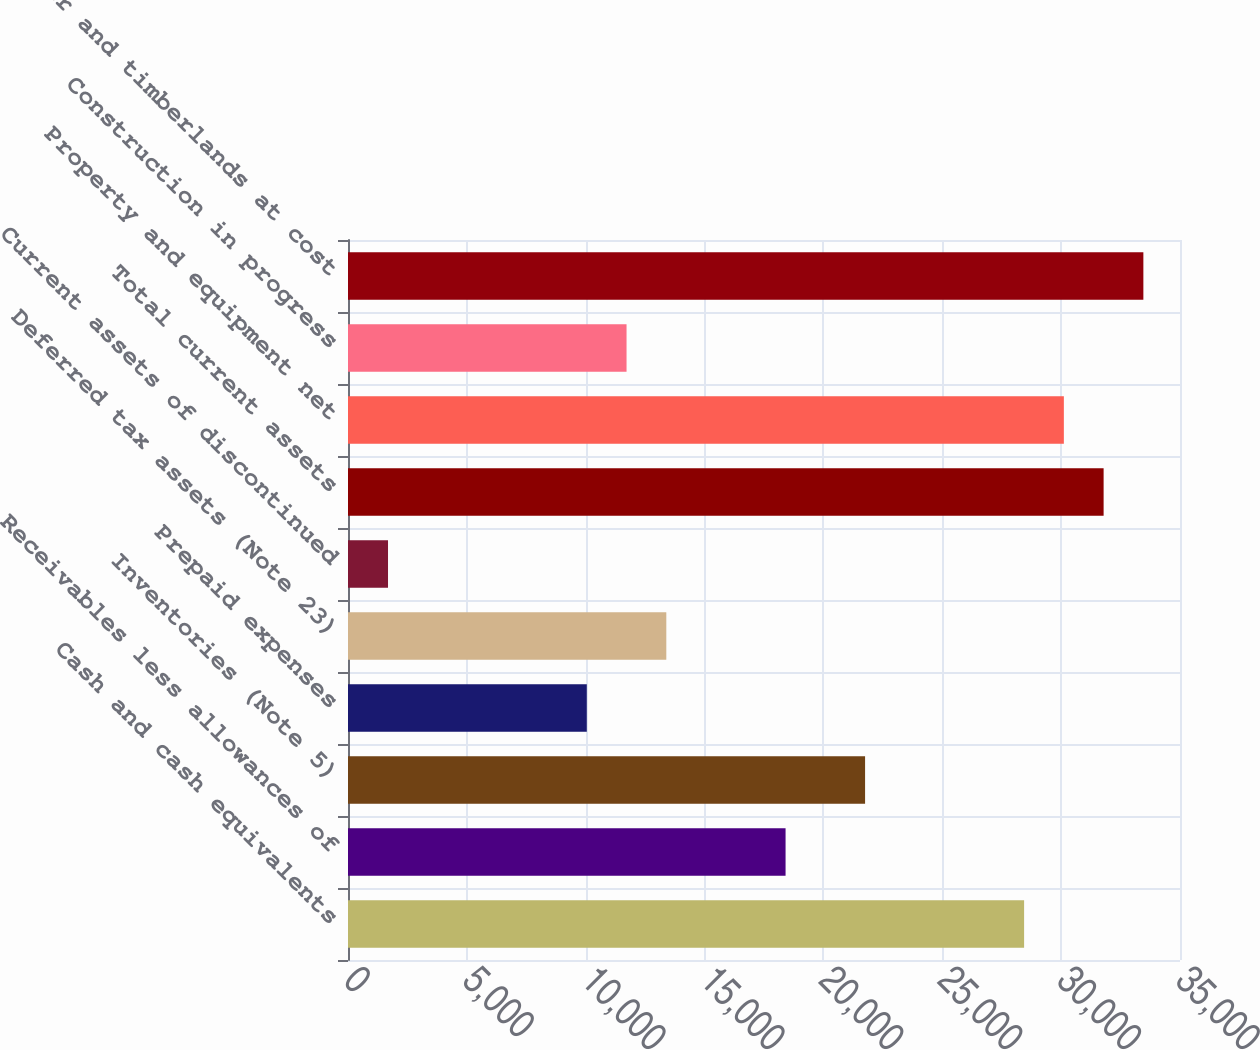<chart> <loc_0><loc_0><loc_500><loc_500><bar_chart><fcel>Cash and cash equivalents<fcel>Receivables less allowances of<fcel>Inventories (Note 5)<fcel>Prepaid expenses<fcel>Deferred tax assets (Note 23)<fcel>Current assets of discontinued<fcel>Total current assets<fcel>Property and equipment net<fcel>Construction in progress<fcel>Timber and timberlands at cost<nl><fcel>28441.8<fcel>18407.4<fcel>21752.2<fcel>10045.4<fcel>13390.2<fcel>1683.4<fcel>31786.6<fcel>30114.2<fcel>11717.8<fcel>33459<nl></chart> 